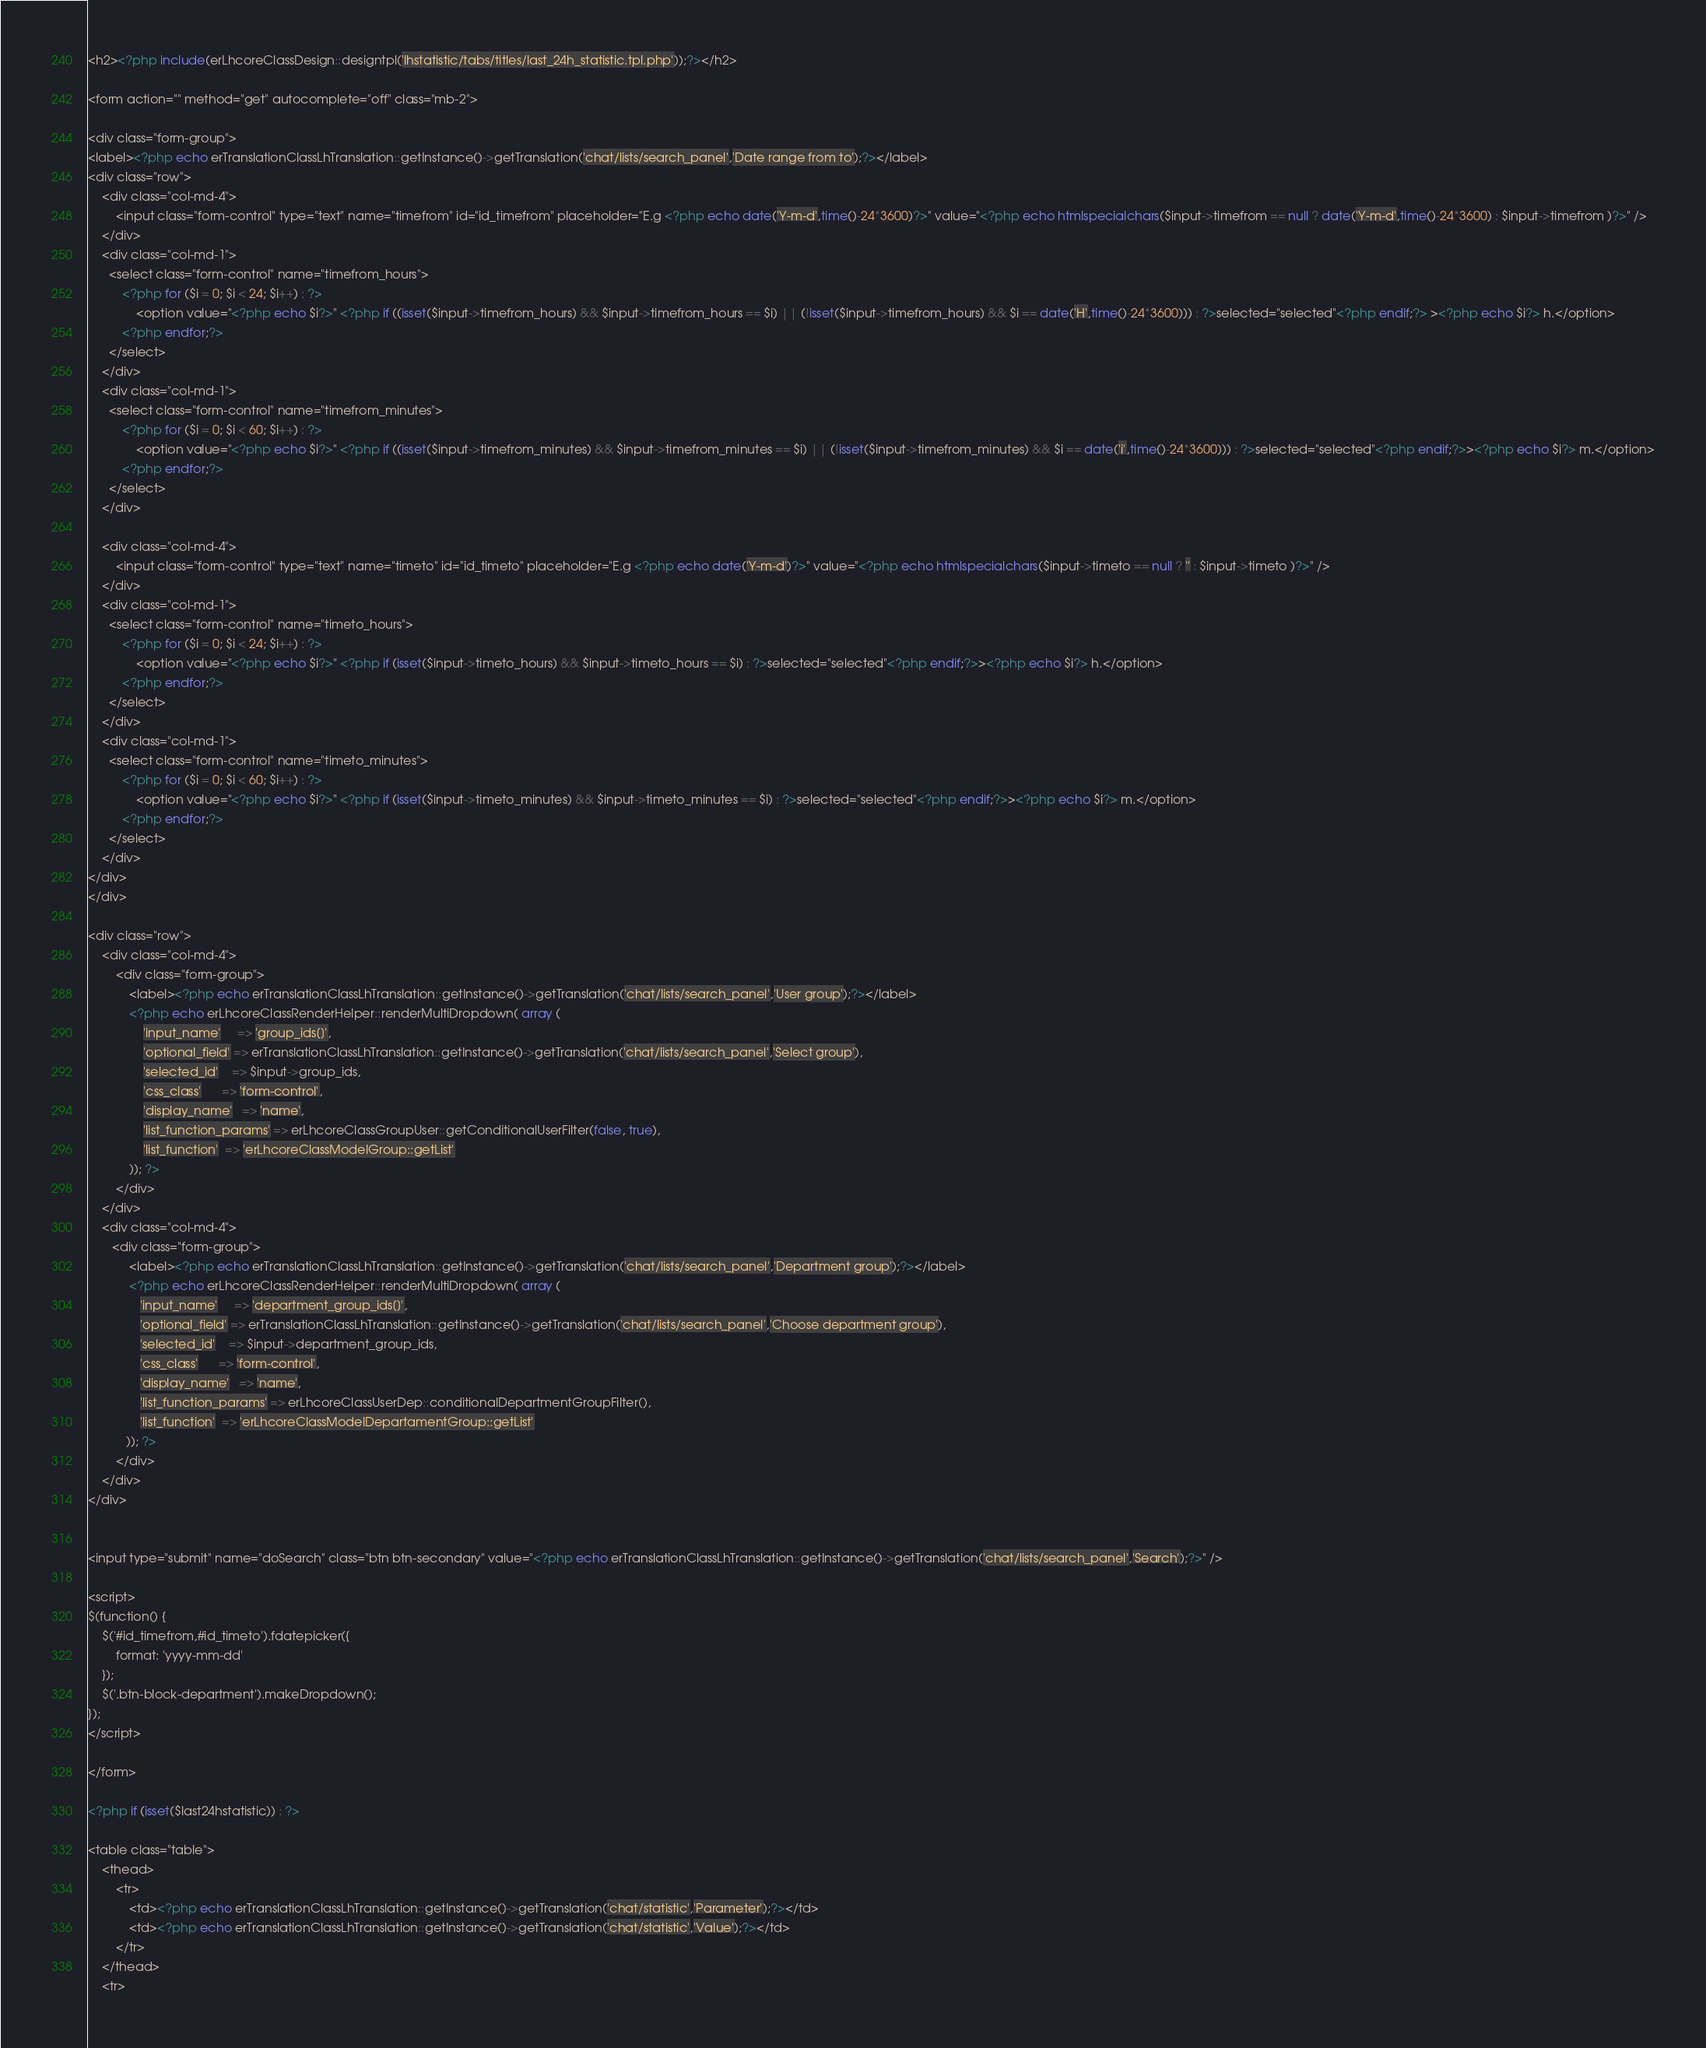<code> <loc_0><loc_0><loc_500><loc_500><_PHP_><h2><?php include(erLhcoreClassDesign::designtpl('lhstatistic/tabs/titles/last_24h_statistic.tpl.php'));?></h2>

<form action="" method="get" autocomplete="off" class="mb-2">

<div class="form-group">
<label><?php echo erTranslationClassLhTranslation::getInstance()->getTranslation('chat/lists/search_panel','Date range from to');?></label>
<div class="row">
	<div class="col-md-4">
		<input class="form-control" type="text" name="timefrom" id="id_timefrom" placeholder="E.g <?php echo date('Y-m-d',time()-24*3600)?>" value="<?php echo htmlspecialchars($input->timefrom == null ? date('Y-m-d',time()-24*3600) : $input->timefrom )?>" />
	</div>
	<div class="col-md-1">
	  <select class="form-control" name="timefrom_hours">
	      <?php for ($i = 0; $i < 24; $i++) : ?>
	          <option value="<?php echo $i?>" <?php if ((isset($input->timefrom_hours) && $input->timefrom_hours == $i) || (!isset($input->timefrom_hours) && $i == date('H',time()-24*3600))) : ?>selected="selected"<?php endif;?> ><?php echo $i?> h.</option>
	      <?php endfor;?>
	  </select>
	</div>
	<div class="col-md-1">
	  <select class="form-control" name="timefrom_minutes">
	      <?php for ($i = 0; $i < 60; $i++) : ?>
	          <option value="<?php echo $i?>" <?php if ((isset($input->timefrom_minutes) && $input->timefrom_minutes == $i) || (!isset($input->timefrom_minutes) && $i == date('i',time()-24*3600))) : ?>selected="selected"<?php endif;?>><?php echo $i?> m.</option>
	      <?php endfor;?>
	  </select>
	</div>
	
	<div class="col-md-4">
		<input class="form-control" type="text" name="timeto" id="id_timeto" placeholder="E.g <?php echo date('Y-m-d')?>" value="<?php echo htmlspecialchars($input->timeto == null ? '' : $input->timeto )?>" />
	</div>
	<div class="col-md-1">
	  <select class="form-control" name="timeto_hours">
	      <?php for ($i = 0; $i < 24; $i++) : ?>
	          <option value="<?php echo $i?>" <?php if (isset($input->timeto_hours) && $input->timeto_hours == $i) : ?>selected="selected"<?php endif;?>><?php echo $i?> h.</option>
	      <?php endfor;?>
	  </select>
	</div>
	<div class="col-md-1">
	  <select class="form-control" name="timeto_minutes">
	      <?php for ($i = 0; $i < 60; $i++) : ?>
	          <option value="<?php echo $i?>" <?php if (isset($input->timeto_minutes) && $input->timeto_minutes == $i) : ?>selected="selected"<?php endif;?>><?php echo $i?> m.</option>
	      <?php endfor;?>
	  </select>
	</div>	
</div>
</div>

<div class="row">
	<div class="col-md-4">
        <div class="form-group">
            <label><?php echo erTranslationClassLhTranslation::getInstance()->getTranslation('chat/lists/search_panel','User group');?></label>
            <?php echo erLhcoreClassRenderHelper::renderMultiDropdown( array (
                'input_name'     => 'group_ids[]',
                'optional_field' => erTranslationClassLhTranslation::getInstance()->getTranslation('chat/lists/search_panel','Select group'),
                'selected_id'    => $input->group_ids,
                'css_class'      => 'form-control',
                'display_name'   => 'name',
                'list_function_params' => erLhcoreClassGroupUser::getConditionalUserFilter(false, true),
                'list_function'  => 'erLhcoreClassModelGroup::getList'
            )); ?>
        </div>
    </div>
    <div class="col-md-4">
	   <div class="form-group">
    	    <label><?php echo erTranslationClassLhTranslation::getInstance()->getTranslation('chat/lists/search_panel','Department group');?></label>
            <?php echo erLhcoreClassRenderHelper::renderMultiDropdown( array (
               'input_name'     => 'department_group_ids[]',
               'optional_field' => erTranslationClassLhTranslation::getInstance()->getTranslation('chat/lists/search_panel','Choose department group'),
               'selected_id'    => $input->department_group_ids,
               'css_class'      => 'form-control',
               'display_name'   => 'name',
               'list_function_params' => erLhcoreClassUserDep::conditionalDepartmentGroupFilter(),
               'list_function'  => 'erLhcoreClassModelDepartamentGroup::getList'
           )); ?>
        </div>   
    </div>
</div>   

    
<input type="submit" name="doSearch" class="btn btn-secondary" value="<?php echo erTranslationClassLhTranslation::getInstance()->getTranslation('chat/lists/search_panel','Search');?>" />

<script>
$(function() {
	$('#id_timefrom,#id_timeto').fdatepicker({
		format: 'yyyy-mm-dd'
	});
    $('.btn-block-department').makeDropdown();
});
</script>	
	
</form>

<?php if (isset($last24hstatistic)) : ?>

<table class="table">
	<thead>
		<tr>
			<td><?php echo erTranslationClassLhTranslation::getInstance()->getTranslation('chat/statistic','Parameter');?></td>
			<td><?php echo erTranslationClassLhTranslation::getInstance()->getTranslation('chat/statistic','Value');?></td>
		</tr>
	</thead>
	<tr></code> 